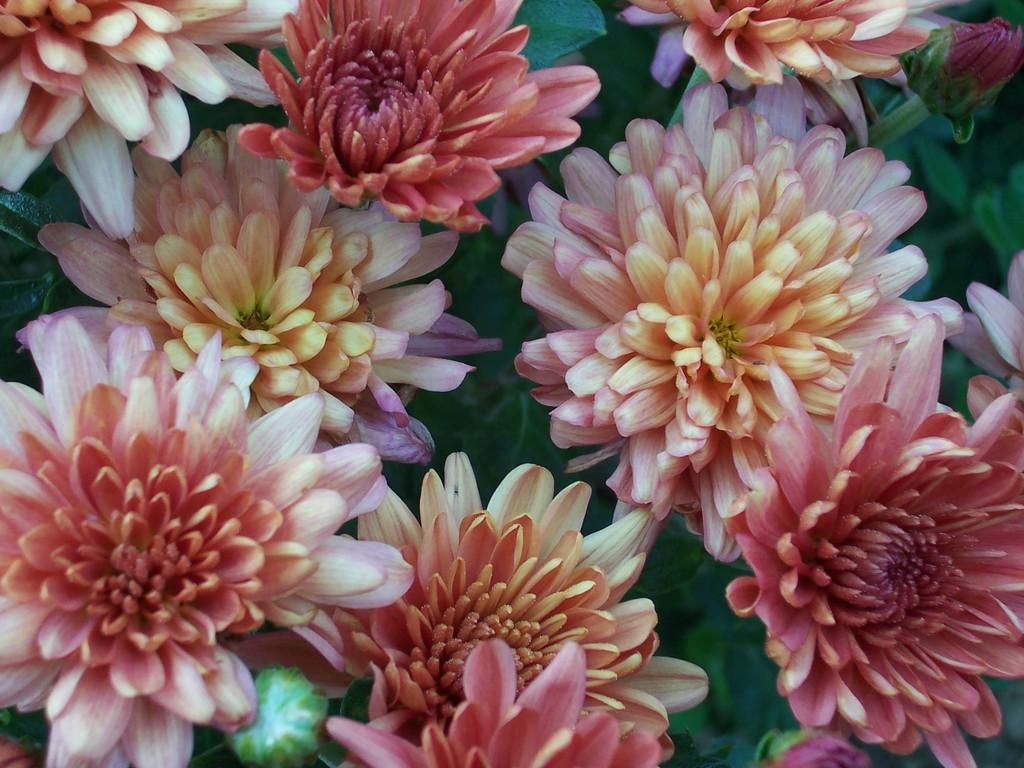What type of plants can be seen in the image? There are flowers in the image. What other parts of the plants are visible in the image? There are leaves in the image. How do the giants use the flowers and leaves in the image? There are no giants present in the image, so it is not possible to answer that question. 